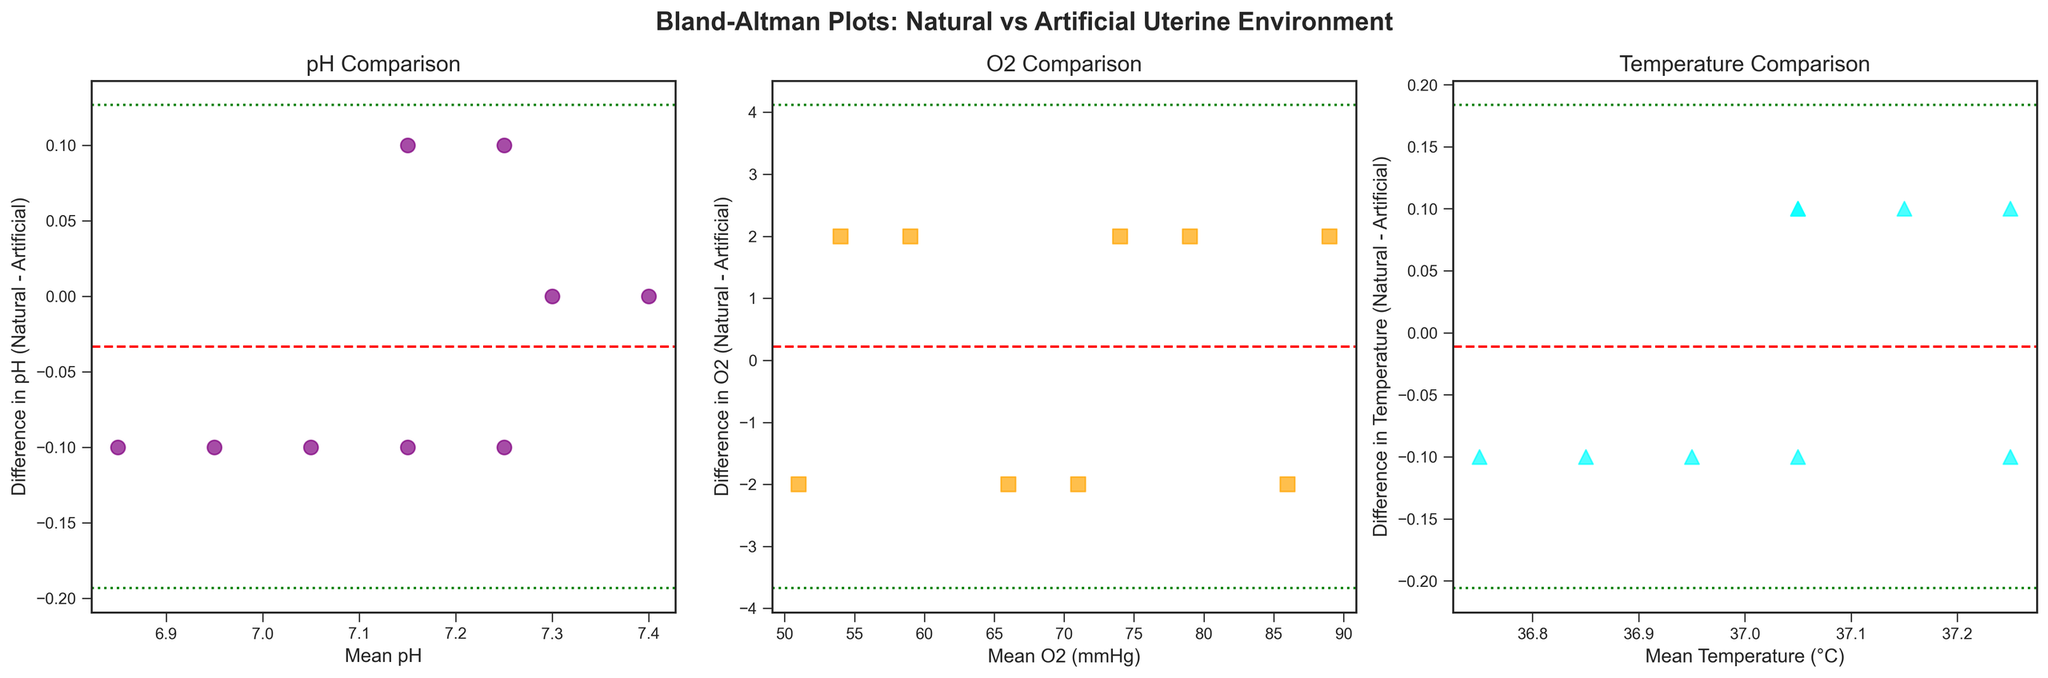How many data points are displayed in the pH comparison plot? Counting the number of points in the purple scatter plot shows there are 9 points
Answer: 9 What is the mean difference in pH values between natural and artificial environments? By observing the horizontal dashed red line in the pH comparison plot, we can see where it intersects the y-axis. This represents the mean difference value, which appears to be close to zero
Answer: Close to zero Which comparison plot has the highest average difference value? Comparing the mean difference lines (dashed red) across all three plots, the O2 comparison plot has the highest average difference since its mean difference line is at a higher level than those of pH and temperature plots.
Answer: O2 comparison plot What are the limits of agreement in the pH comparison plot? The limits of agreement are represented by the green dotted lines, which show the mean difference ± 1.96 times the standard deviation. For the pH plot, these limits are approximately -0.2 and +0.2.
Answer: -0.2 and +0.2 Which parameter shows the least variance in the differences between natural and artificial environments? The parameter with the least variance will have the narrowest spread of points around the mean difference line. Observing the scatter plots, the temperature comparison shows the least variance with points closely clustered around the mean difference line.
Answer: Temperature comparison What is the mean value of oxygen levels in the artificial environment at day 60? Referring to the dataset provided, the artificial oxygen level at day 60 is 53 mmHg
Answer: 53 mmHg How does the range of differences in oxygen levels compare to the range of differences in pH values? The range of differences is represented by the spread of points along the y-axis in each plot. The oxygen level differences (approx. -2 to +2 mmHg) are smaller than the pH differences (approx. -0.1 to +0.1). This indicates the pH differences have a slightly larger range.
Answer: pH differences have a slightly larger range On which day does the temperature difference between natural and artificial environments exceed 0.1°C? From the temperature difference plot, we identify the point where the difference exceeds 0.1°C. This occurs around day 60 where the difference is indicated to be exactly 0.1°C but does not exceed it in other days.
Answer: It does not exceed 0.1°C What is the relationship between mean values and differences in the Bland-Altman plots? In Bland-Altman plots, points are dispersed around the mean difference line to show if differences depend on the mean: ideally, differences should be randomly scattered without any pattern relative to the mean value
Answer: Points should be randomly scattered without a pattern 